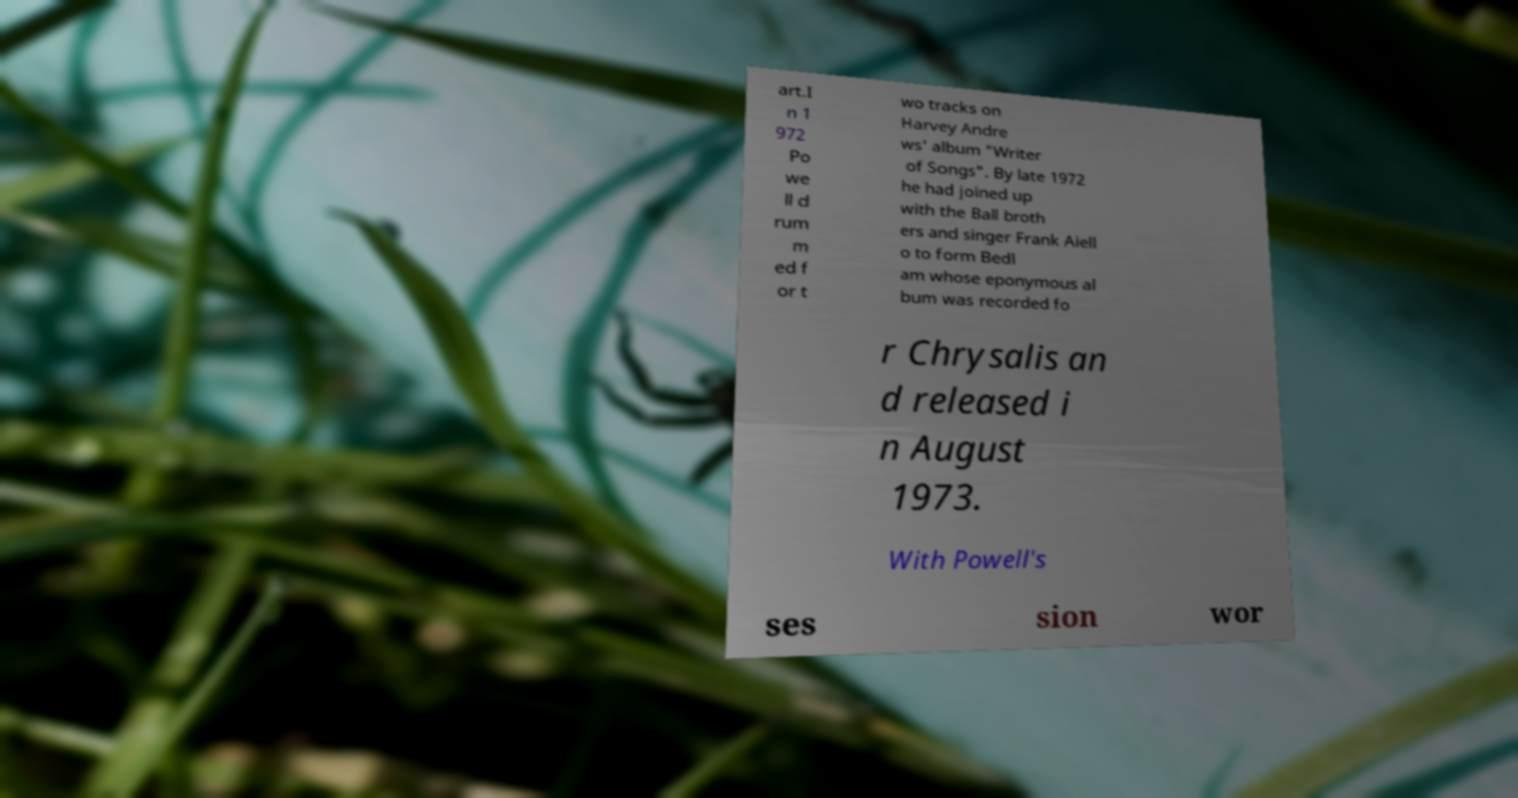What messages or text are displayed in this image? I need them in a readable, typed format. art.I n 1 972 Po we ll d rum m ed f or t wo tracks on Harvey Andre ws' album "Writer of Songs". By late 1972 he had joined up with the Ball broth ers and singer Frank Aiell o to form Bedl am whose eponymous al bum was recorded fo r Chrysalis an d released i n August 1973. With Powell's ses sion wor 